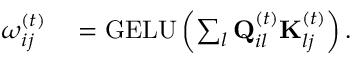<formula> <loc_0><loc_0><loc_500><loc_500>\begin{array} { r l } { \omega _ { i j } ^ { ( t ) } } & = G E L U \left ( \sum _ { l } Q _ { i l } ^ { ( t ) } K _ { l j } ^ { ( t ) } \right ) . } \end{array}</formula> 